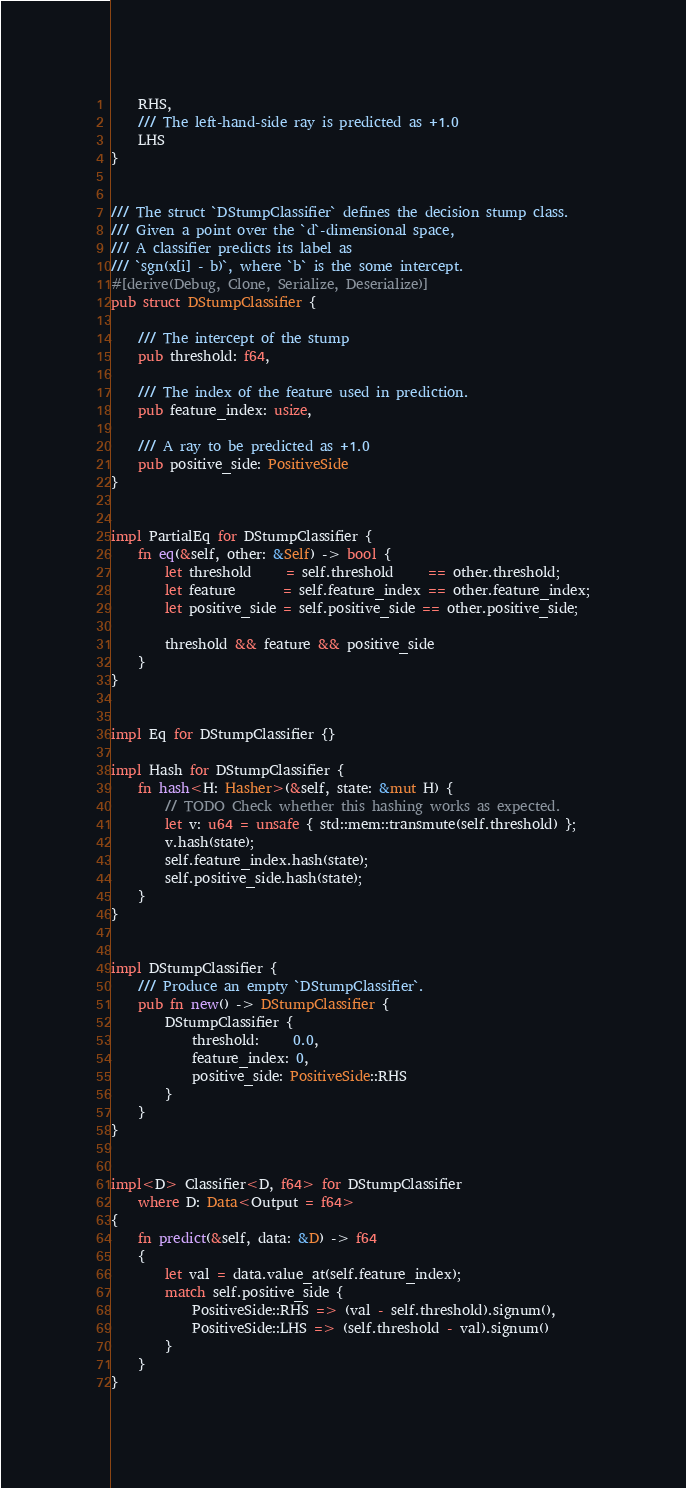Convert code to text. <code><loc_0><loc_0><loc_500><loc_500><_Rust_>    RHS,
    /// The left-hand-side ray is predicted as +1.0
    LHS
}


/// The struct `DStumpClassifier` defines the decision stump class.
/// Given a point over the `d`-dimensional space,
/// A classifier predicts its label as
/// `sgn(x[i] - b)`, where `b` is the some intercept.
#[derive(Debug, Clone, Serialize, Deserialize)]
pub struct DStumpClassifier {

    /// The intercept of the stump
    pub threshold: f64,

    /// The index of the feature used in prediction.
    pub feature_index: usize,

    /// A ray to be predicted as +1.0
    pub positive_side: PositiveSide
}


impl PartialEq for DStumpClassifier {
    fn eq(&self, other: &Self) -> bool {
        let threshold     = self.threshold     == other.threshold;
        let feature       = self.feature_index == other.feature_index;
        let positive_side = self.positive_side == other.positive_side;

        threshold && feature && positive_side
    }
}


impl Eq for DStumpClassifier {}

impl Hash for DStumpClassifier {
    fn hash<H: Hasher>(&self, state: &mut H) {
        // TODO Check whether this hashing works as expected.
        let v: u64 = unsafe { std::mem::transmute(self.threshold) };
        v.hash(state);
        self.feature_index.hash(state);
        self.positive_side.hash(state);
    }
}


impl DStumpClassifier {
    /// Produce an empty `DStumpClassifier`.
    pub fn new() -> DStumpClassifier {
        DStumpClassifier {
            threshold:     0.0,
            feature_index: 0,
            positive_side: PositiveSide::RHS
        }
    }
}


impl<D> Classifier<D, f64> for DStumpClassifier
    where D: Data<Output = f64>
{
    fn predict(&self, data: &D) -> f64
    {
        let val = data.value_at(self.feature_index);
        match self.positive_side {
            PositiveSide::RHS => (val - self.threshold).signum(),
            PositiveSide::LHS => (self.threshold - val).signum()
        }
    }
}

</code> 